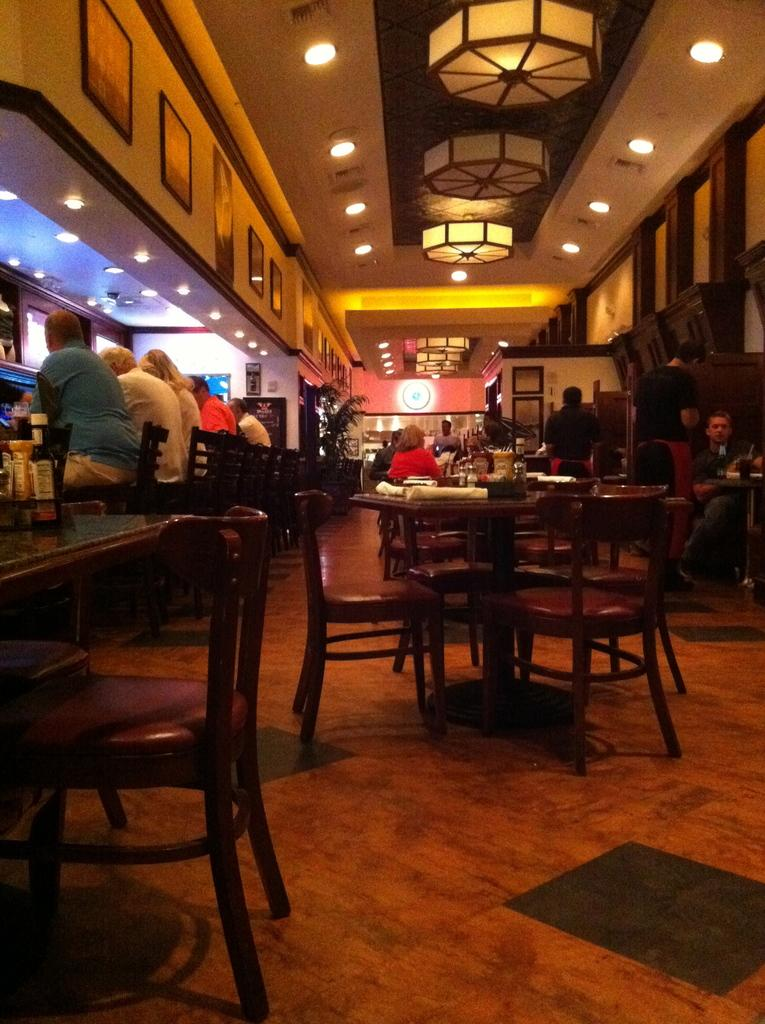What is visible above the people in the image? There is a ceiling visible in the image, and lights are on the ceiling. What are the people in the image doing? The persons in the image are sitting on chairs. What type of furniture is present in the image? There are tables in the image. What is the surface beneath the people in the image? The image depicts a floor. Can you see any plastic items in the image? There is no information about plastic items in the provided facts, so we cannot determine if any are present in the image. Is there a plane visible in the image? There is no mention of a plane in the provided facts, so we cannot determine if one is present in the image. 